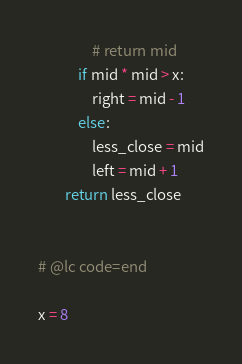Convert code to text. <code><loc_0><loc_0><loc_500><loc_500><_Python_>                # return mid
            if mid * mid > x:
                right = mid - 1
            else:
                less_close = mid
                left = mid + 1
        return less_close


# @lc code=end

x = 8
</code> 